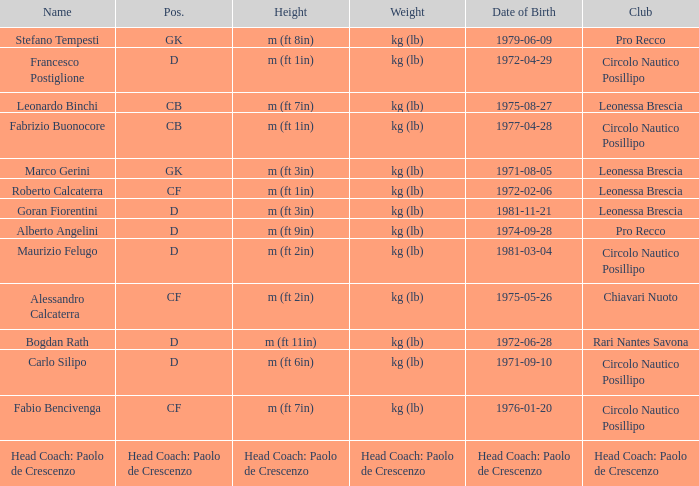What is the name of the player from club Circolo Nautico Posillipo and a position of D? Francesco Postiglione, Maurizio Felugo, Carlo Silipo. 